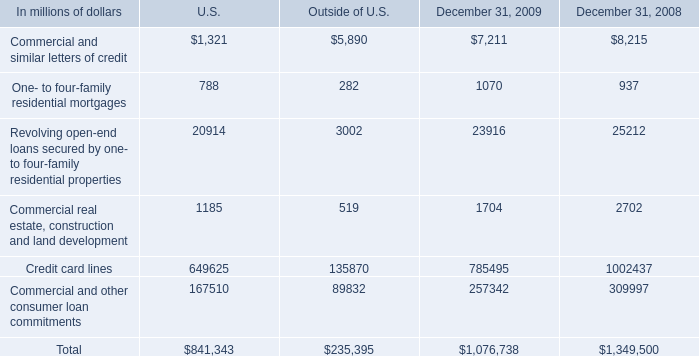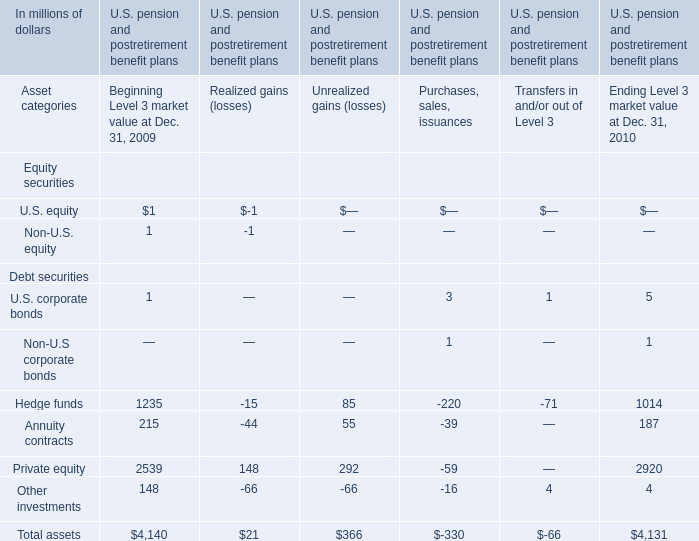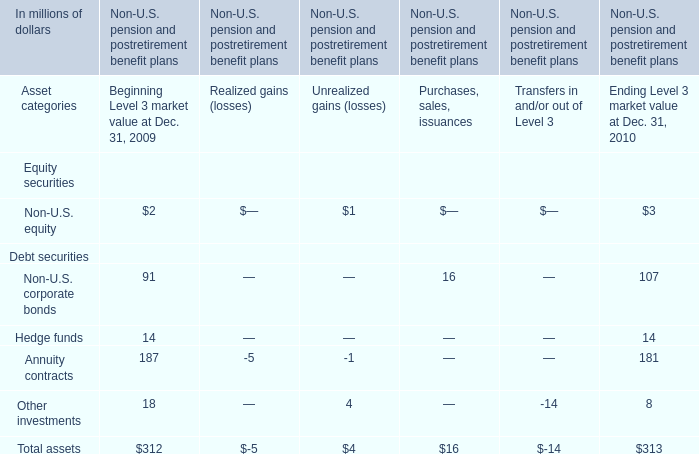What is the ratio of Hedge funds to the total assets for Beginning Level 3 market value at Dec. 31, 2009? 
Computations: (14 / 312)
Answer: 0.04487. 